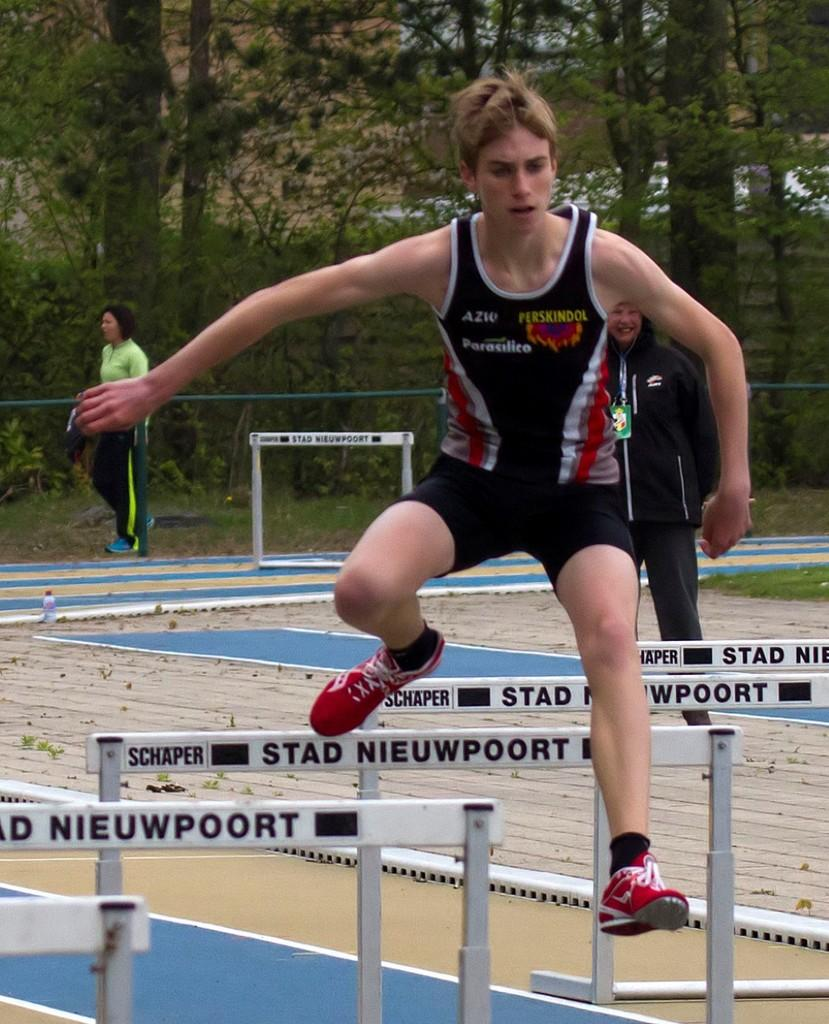<image>
Provide a brief description of the given image. A young man jumping over hurdles marked Stad nieuwpoort, wearing a shirt sponsored by Perskindol, AZW and Parasilico. 